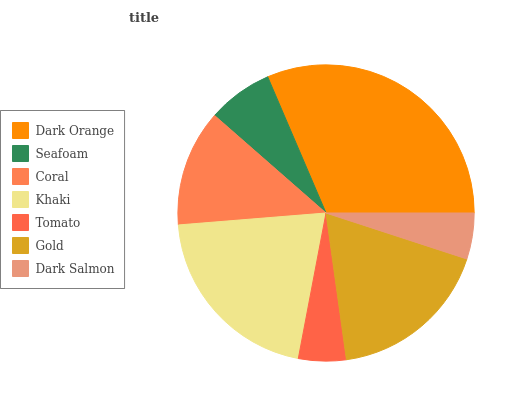Is Dark Salmon the minimum?
Answer yes or no. Yes. Is Dark Orange the maximum?
Answer yes or no. Yes. Is Seafoam the minimum?
Answer yes or no. No. Is Seafoam the maximum?
Answer yes or no. No. Is Dark Orange greater than Seafoam?
Answer yes or no. Yes. Is Seafoam less than Dark Orange?
Answer yes or no. Yes. Is Seafoam greater than Dark Orange?
Answer yes or no. No. Is Dark Orange less than Seafoam?
Answer yes or no. No. Is Coral the high median?
Answer yes or no. Yes. Is Coral the low median?
Answer yes or no. Yes. Is Gold the high median?
Answer yes or no. No. Is Dark Orange the low median?
Answer yes or no. No. 